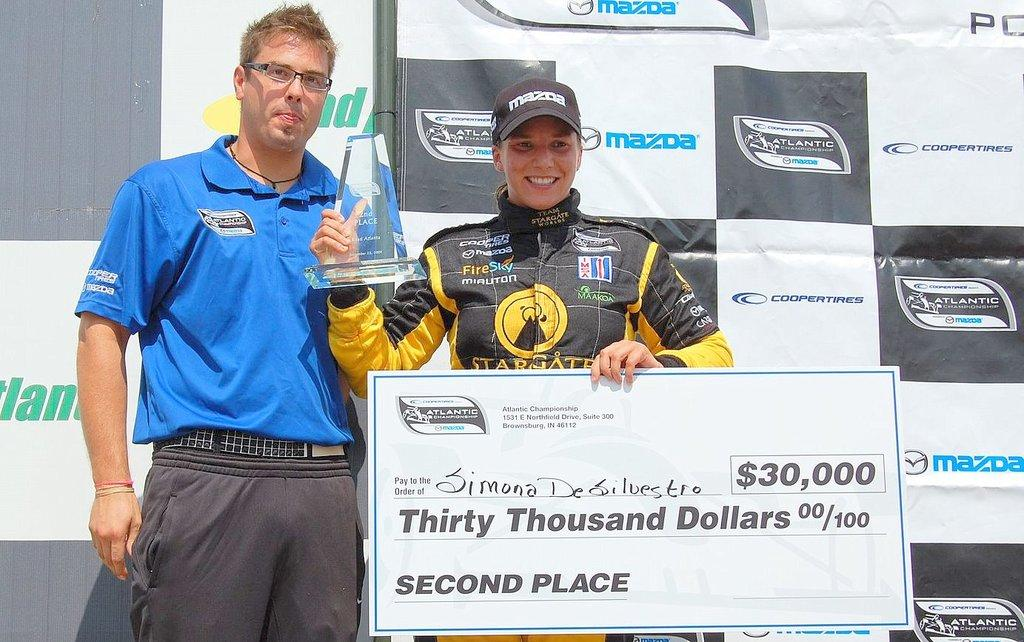<image>
Offer a succinct explanation of the picture presented. a race car drive holding a check for thirty thousand dollars 